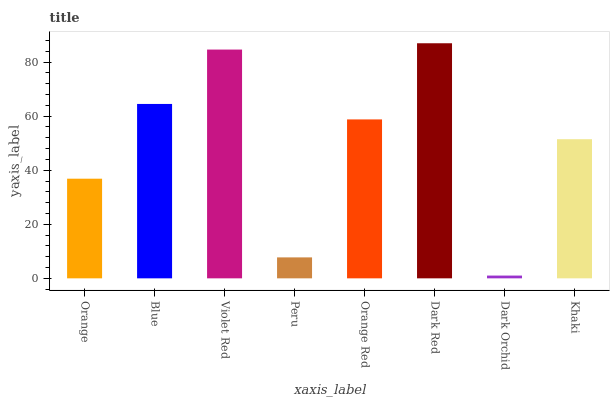Is Blue the minimum?
Answer yes or no. No. Is Blue the maximum?
Answer yes or no. No. Is Blue greater than Orange?
Answer yes or no. Yes. Is Orange less than Blue?
Answer yes or no. Yes. Is Orange greater than Blue?
Answer yes or no. No. Is Blue less than Orange?
Answer yes or no. No. Is Orange Red the high median?
Answer yes or no. Yes. Is Khaki the low median?
Answer yes or no. Yes. Is Blue the high median?
Answer yes or no. No. Is Dark Orchid the low median?
Answer yes or no. No. 